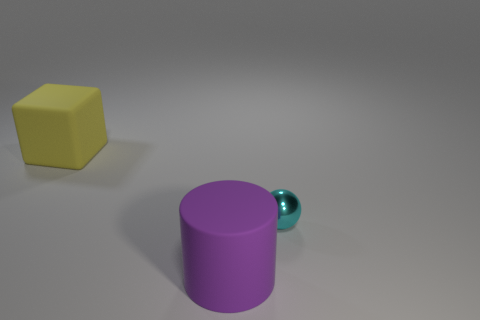Add 2 large yellow metal blocks. How many objects exist? 5 Subtract all balls. How many objects are left? 2 Subtract 0 gray cubes. How many objects are left? 3 Subtract all cubes. Subtract all matte cylinders. How many objects are left? 1 Add 2 big yellow objects. How many big yellow objects are left? 3 Add 3 shiny things. How many shiny things exist? 4 